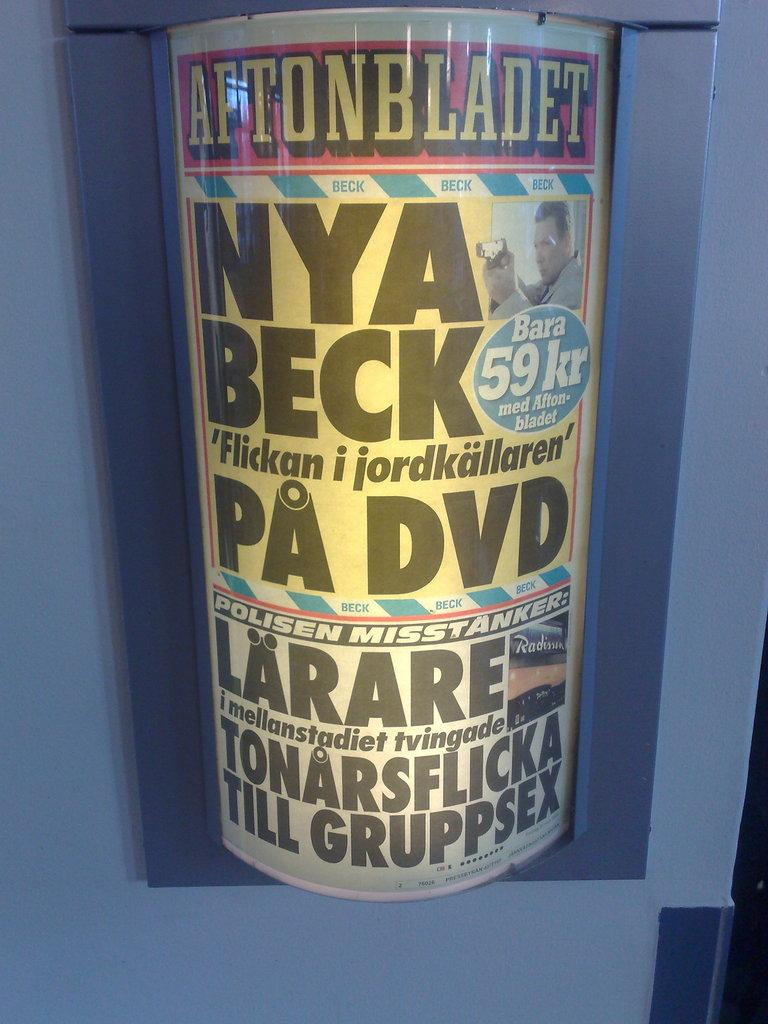What object is present in the image that can hold items? There is a tin in the image that can hold items. What is inside the tin in the image? There is a note in the tin. What type of bird can be seen flying around the tin in the image? There are no birds present in the image; it only features a tin and a note inside it. 